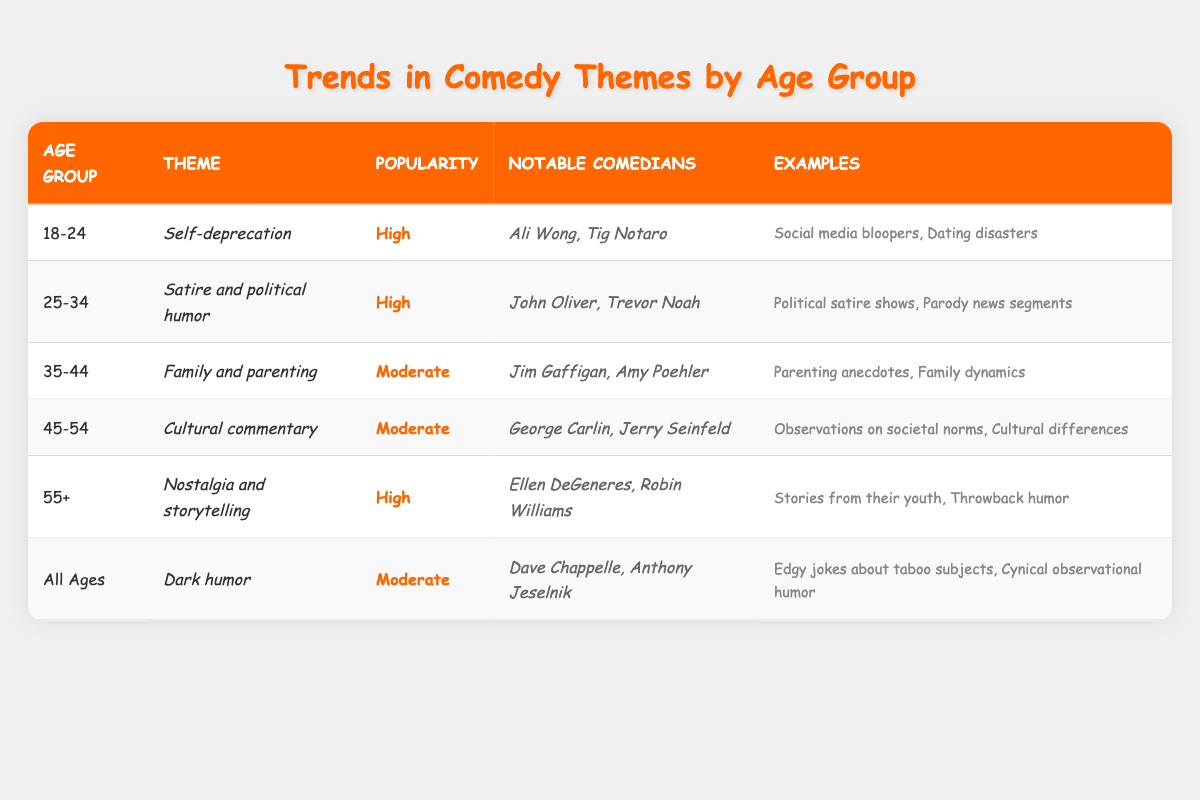What theme is preferred by the 18-24 age group? The table indicates that the preferred theme for the 18-24 age group is *Self-deprecation*.
Answer: Self-deprecation Which comedians are notable for the 25-34 age group? Referring to the table, the notable comedians for the 25-34 age group are John Oliver and Trevor Noah.
Answer: John Oliver, Trevor Noah Is the popularity of *Dark humor* high? According to the table, the popularity of *Dark humor* is categorized as moderate, not high.
Answer: No What is the average popularity rating among all age groups presented in the table? The popularity ratings are High, High, Moderate, Moderate, High, and Moderate. Assigning numerical values: High = 2, Moderate = 1, we sum the values: 2 + 2 + 1 + 1 + 2 + 1 = 9. There are 6 age groups, so the average is 9/6 = 1.5, which translates to between Moderate and High.
Answer: Moderate to High Which age group has the same theme popularity as the 35-44 age group? The 35-44 age group has a theme popularity of Moderate. Checking the table, the 45-54 age group also has a popularity of Moderate.
Answer: 45-54 age group What are the examples given for the *Cultural commentary* theme? The table states that the examples for the *Cultural commentary* theme include observations on societal norms and cultural differences.
Answer: Observations on societal norms, Cultural differences How many notable comedians are associated with the *Nostalgia and storytelling* theme? The table lists 2 notable comedians associated with the *Nostalgia and storytelling* theme: Ellen DeGeneres and Robin Williams.
Answer: 2 Which theme is unique to the 'All Ages' group and what is its popularity? The *Dark humor* theme is unique to the All Ages group, and its popularity is classified as moderate.
Answer: Dark humor, Moderate If you combine the notable comedians from the 45-54 and 55+ age groups, how many unique comedians are there? The 45-54 age group has George Carlin and Jerry Seinfeld, while the 55+ age group has Ellen DeGeneres and Robin Williams. All four comedians are unique and there are no overlaps. Thus, the total unique comedians are 4.
Answer: 4 